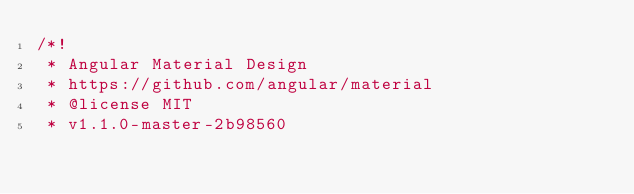Convert code to text. <code><loc_0><loc_0><loc_500><loc_500><_CSS_>/*!
 * Angular Material Design
 * https://github.com/angular/material
 * @license MIT
 * v1.1.0-master-2b98560</code> 